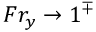Convert formula to latex. <formula><loc_0><loc_0><loc_500><loc_500>F r _ { y } \to 1 ^ { \mp }</formula> 